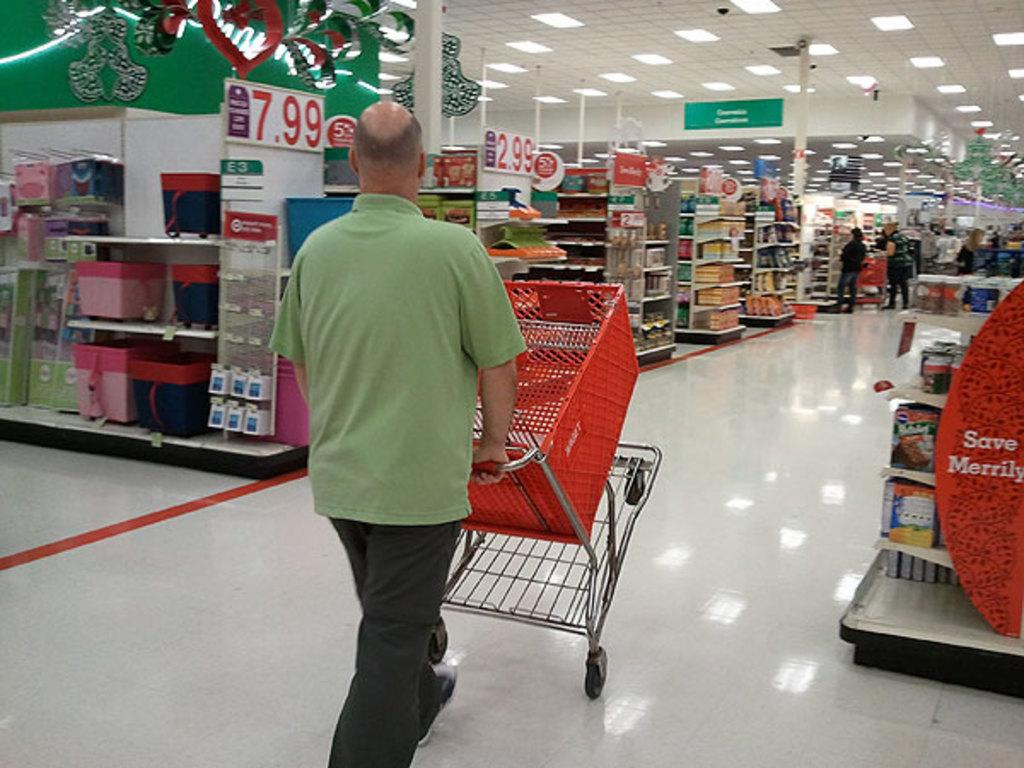Provide a one-sentence caption for the provided image. A man is doing a wheely with his shopping cart next to a sign that says "save merrily". 